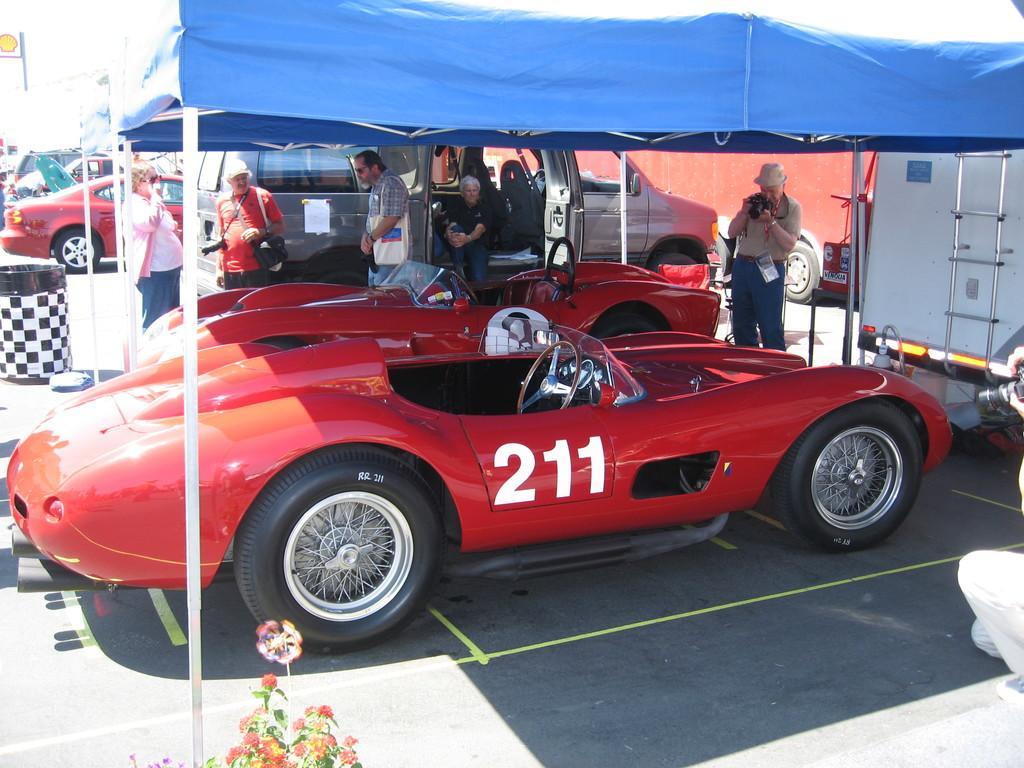Please provide a concise description of this image. There are many vehicles. Some people are there. Some are holding cameras. Also there are tents. On the right side there is a vehicle with ladder. On the left side there is a bin. At the bottom there is a plant with flowers. 